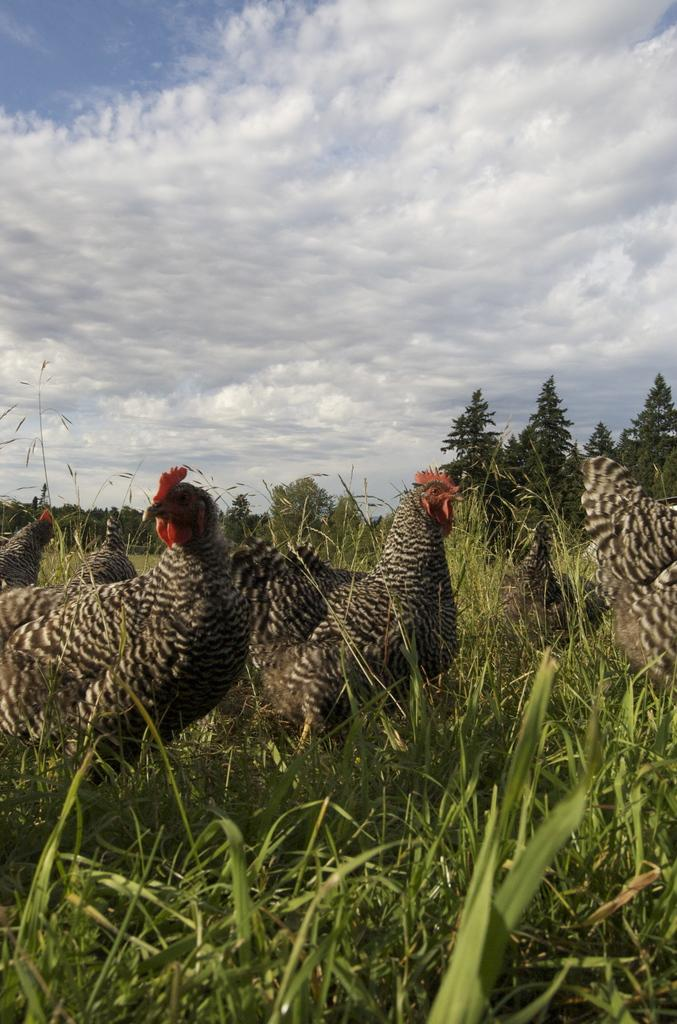What type of animals can be seen in the image? There are birds in the image. What colors are the birds in the image? The birds are in brown and red colors. What type of vegetation is present in the image? There are trees in the image. What color are the trees in the image? The trees are in green color. What is visible in the background of the image? The sky is visible in the background of the image. What colors are the sky in the image? The sky is in white and blue colors. What type of cake is being served in the image? There is no cake present in the image; it features birds and trees. Can you tell me how many pockets are visible in the image? There are no pockets visible in the image. 